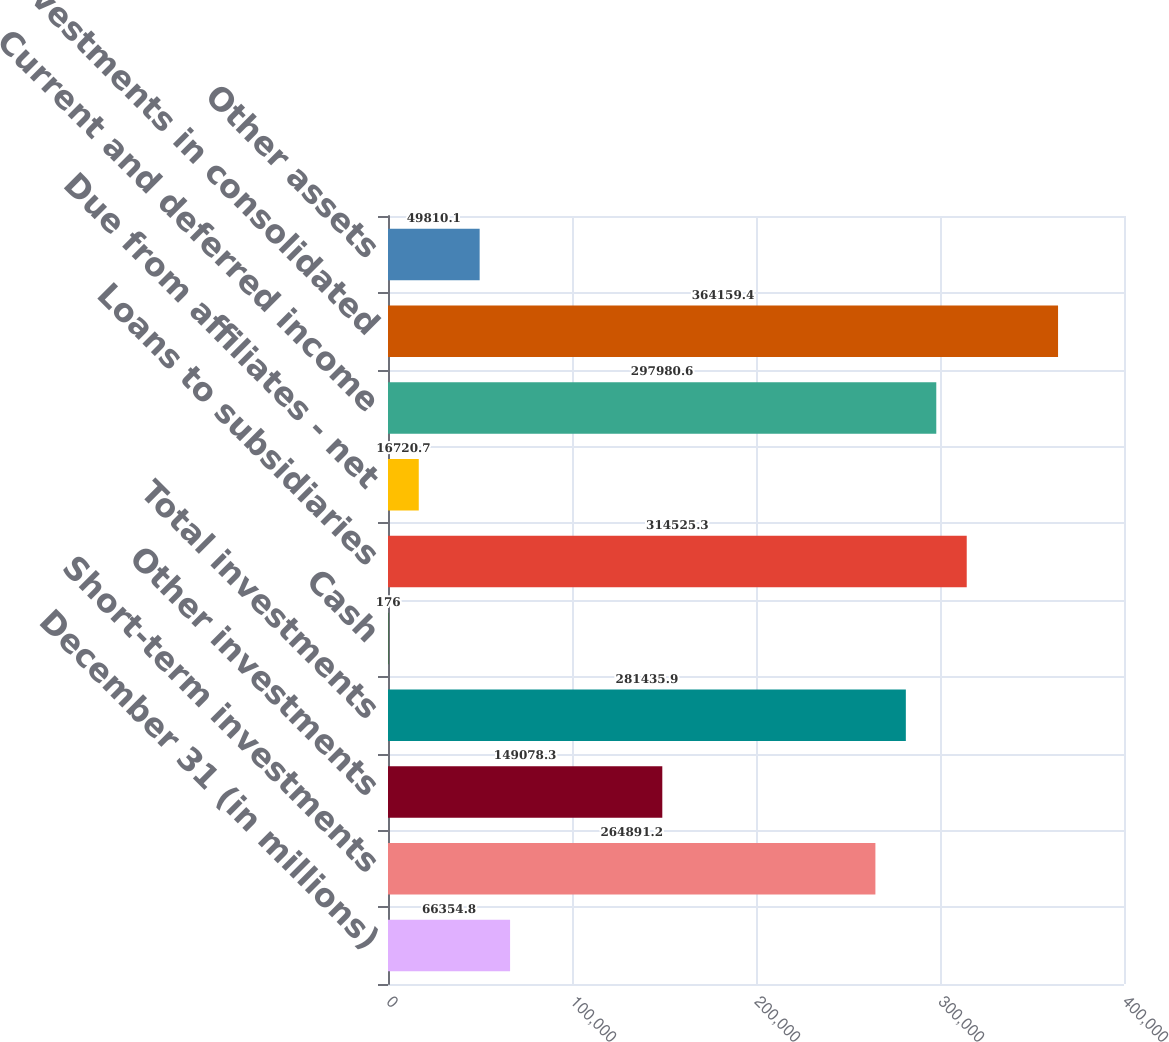Convert chart. <chart><loc_0><loc_0><loc_500><loc_500><bar_chart><fcel>December 31 (in millions)<fcel>Short-term investments<fcel>Other investments<fcel>Total investments<fcel>Cash<fcel>Loans to subsidiaries<fcel>Due from affiliates - net<fcel>Current and deferred income<fcel>Investments in consolidated<fcel>Other assets<nl><fcel>66354.8<fcel>264891<fcel>149078<fcel>281436<fcel>176<fcel>314525<fcel>16720.7<fcel>297981<fcel>364159<fcel>49810.1<nl></chart> 